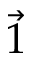<formula> <loc_0><loc_0><loc_500><loc_500>\vec { 1 }</formula> 